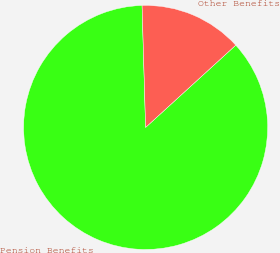Convert chart. <chart><loc_0><loc_0><loc_500><loc_500><pie_chart><fcel>Pension Benefits<fcel>Other Benefits<nl><fcel>86.31%<fcel>13.69%<nl></chart> 